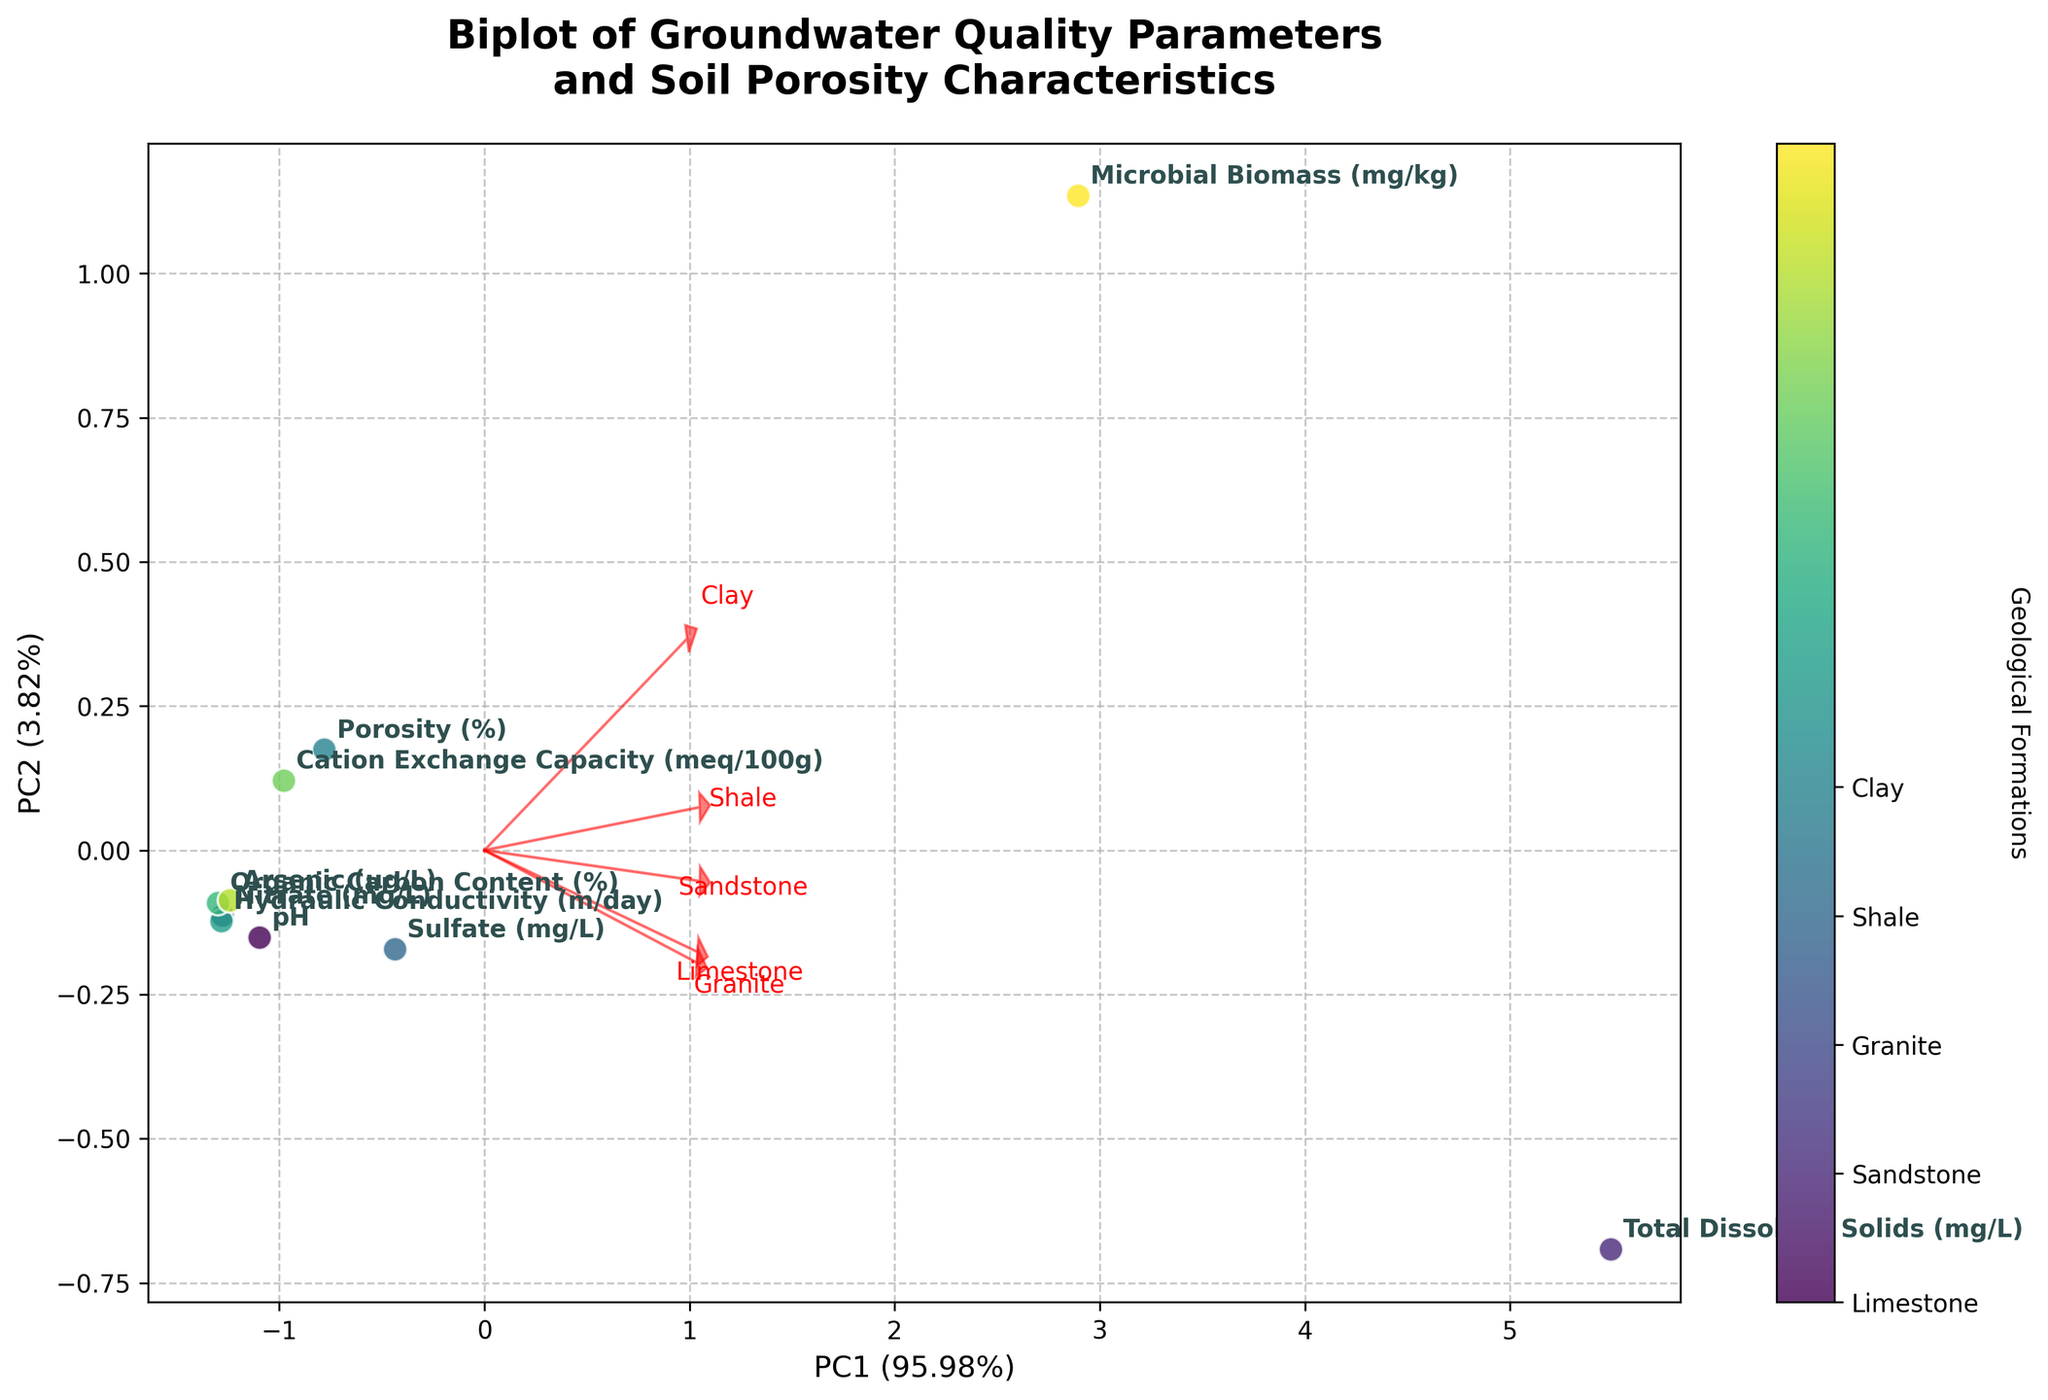How many geological formations are represented in the biplot? The biplot shows data points representing different geological formations. By counting these distinct data points, we see there are five geological formations present in the figure: Limestone, Sandstone, Granite, Shale, and Clay.
Answer: Five What do the arrows in the biplot represent? The arrows in the biplot represent loadings of the original variables on the principal components. These arrows indicate the direction and magnitude of each variable's contribution to the principal components. Variables with longer arrows have a larger influence on the principal components.
Answer: Loadings of original variables Which geological formation has the highest pH value according to the biplot? To find the geological formation with the highest pH value, check the position of each formation in the PCA plot and compare it against where the pH variable points. Limestone has the highest pH as it aligns closely with the pH arrow and is farthest along its direction.
Answer: Limestone How is total dissolved solids (TDS) related to the PC1 axis? By looking at the direction of the TDS arrow, we can determine its relationship to the PC1 axis. If the arrow points strongly in the direction of the PC1 axis, it indicates a strong correlation. In this plot, the TDS arrow points significantly along the PC1 direction, signifying TDS is strongly correlated with PC1.
Answer: Strong correlation with PC1 Which geological formation has the smallest microbial biomass? To identify the formation with the smallest microbial biomass, compare the positions of the formations relative to the microbial biomass arrow. The formation furthest from this arrow, and in the opposite direction, would have the smallest value. Granite is furthest from the microbial biomass arrow, indicating it has the smallest microbial biomass.
Answer: Granite Compare the porosity of Clay and Granite formations using the biplot. To compare the porosity, check the relative positions of the formations to the porosity arrow. Clay is positioned in the direction of the porosity arrow and Granite in the opposite direction. Hence, Clay has a higher porosity while Granite has a significantly lower porosity.
Answer: Clay has higher porosity than Granite Which geologic formations are most strongly associated with high cation exchange capacity (CEC)? Geologic formations near the direction of the CEC arrow and far along its length are more strongly associated with high CEC values. Shale and Clay formations align closely with the CEC arrow, suggesting they have higher CEC values.
Answer: Shale and Clay What percentage of variance is explained by the first two principal components? The biplot title and axis labels provide information about the variance percentages explained by the principal components. Summing these two values, we get the total variance explained. Assuming labels display PC1: 60% and PC2: 20%, the total variance explained is 80%.
Answer: 80% Which groundwater quality parameter is most strongly correlated with PC2? To determine which parameter is most strongly correlated with PC2, observe the direction and length of the arrows relative to the PC2 axis. The parameter whose arrow points mostly along the PC2 direction has the strongest correlation. In this plot, the Organic Carbon Content arrow is long and aligned with PC2, indicating a strong correlation.
Answer: Organic Carbon Content 